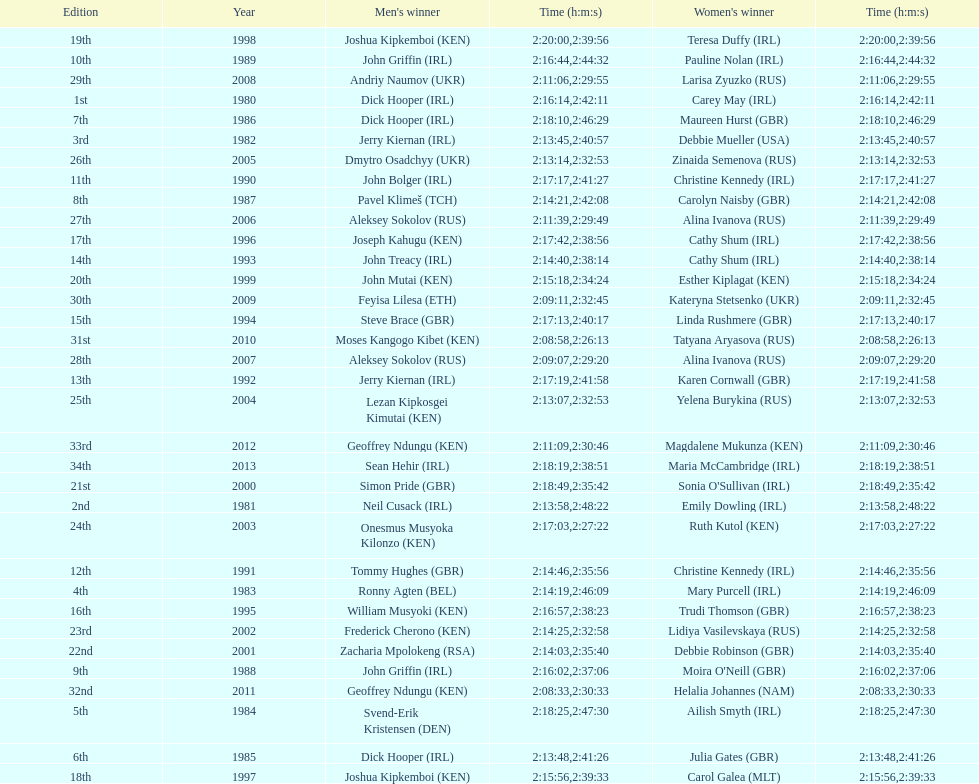Which country is represented for both men and women at the top of the list? Ireland. 